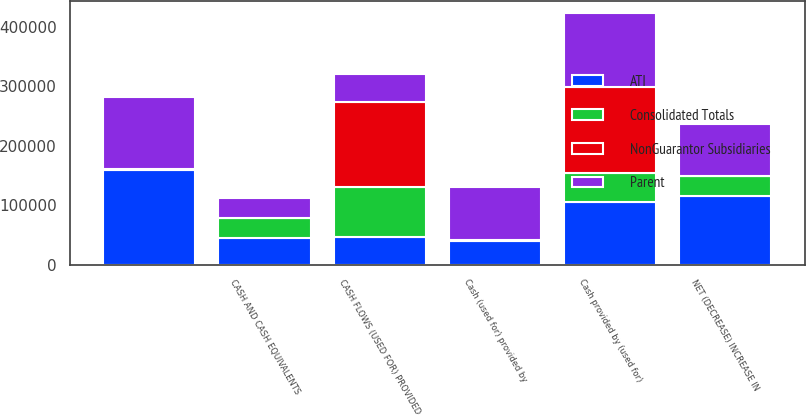Convert chart to OTSL. <chart><loc_0><loc_0><loc_500><loc_500><stacked_bar_chart><ecel><fcel>CASH FLOWS (USED FOR) PROVIDED<fcel>Cash (used for) provided by<fcel>Cash provided by (used for)<fcel>NET (DECREASE) INCREASE IN<fcel>CASH AND CASH EQUIVALENTS<fcel>Unnamed: 6<nl><fcel>Consolidated Totals<fcel>82965<fcel>263<fcel>49545<fcel>33683<fcel>35010<fcel>1327<nl><fcel>ATI<fcel>46759<fcel>40437<fcel>105039<fcel>115702<fcel>43973<fcel>159675<nl><fcel>NonGuarantor Subsidiaries<fcel>144001<fcel>469<fcel>144469<fcel>1<fcel>110<fcel>111<nl><fcel>Parent<fcel>46759<fcel>88881<fcel>123100<fcel>86543<fcel>33608<fcel>120151<nl></chart> 